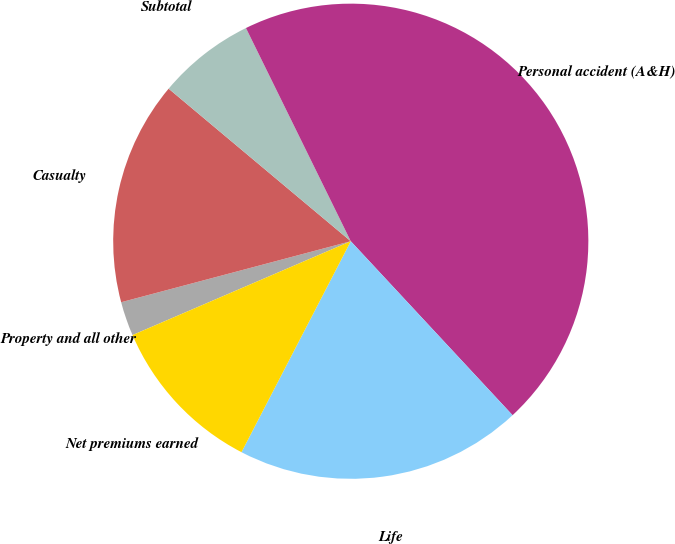Convert chart. <chart><loc_0><loc_0><loc_500><loc_500><pie_chart><fcel>Property and all other<fcel>Casualty<fcel>Subtotal<fcel>Personal accident (A&H)<fcel>Life<fcel>Net premiums earned<nl><fcel>2.33%<fcel>15.23%<fcel>6.63%<fcel>45.35%<fcel>19.53%<fcel>10.93%<nl></chart> 